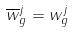<formula> <loc_0><loc_0><loc_500><loc_500>\overline { w } _ { g } ^ { j } = w _ { g } ^ { j }</formula> 